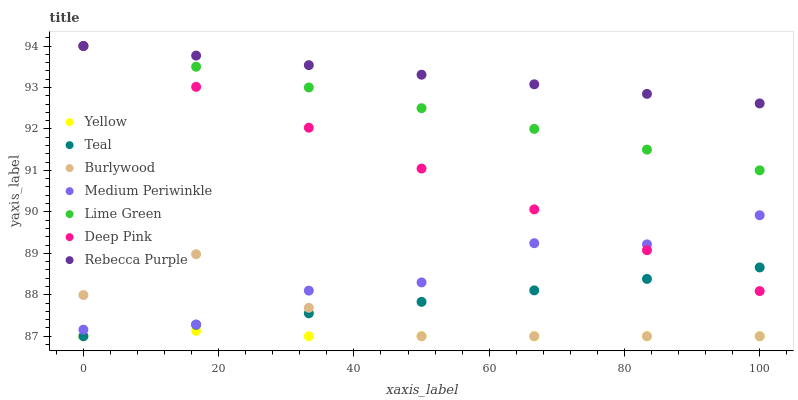Does Yellow have the minimum area under the curve?
Answer yes or no. Yes. Does Rebecca Purple have the maximum area under the curve?
Answer yes or no. Yes. Does Burlywood have the minimum area under the curve?
Answer yes or no. No. Does Burlywood have the maximum area under the curve?
Answer yes or no. No. Is Teal the smoothest?
Answer yes or no. Yes. Is Medium Periwinkle the roughest?
Answer yes or no. Yes. Is Burlywood the smoothest?
Answer yes or no. No. Is Burlywood the roughest?
Answer yes or no. No. Does Burlywood have the lowest value?
Answer yes or no. Yes. Does Medium Periwinkle have the lowest value?
Answer yes or no. No. Does Lime Green have the highest value?
Answer yes or no. Yes. Does Burlywood have the highest value?
Answer yes or no. No. Is Teal less than Lime Green?
Answer yes or no. Yes. Is Lime Green greater than Medium Periwinkle?
Answer yes or no. Yes. Does Yellow intersect Burlywood?
Answer yes or no. Yes. Is Yellow less than Burlywood?
Answer yes or no. No. Is Yellow greater than Burlywood?
Answer yes or no. No. Does Teal intersect Lime Green?
Answer yes or no. No. 